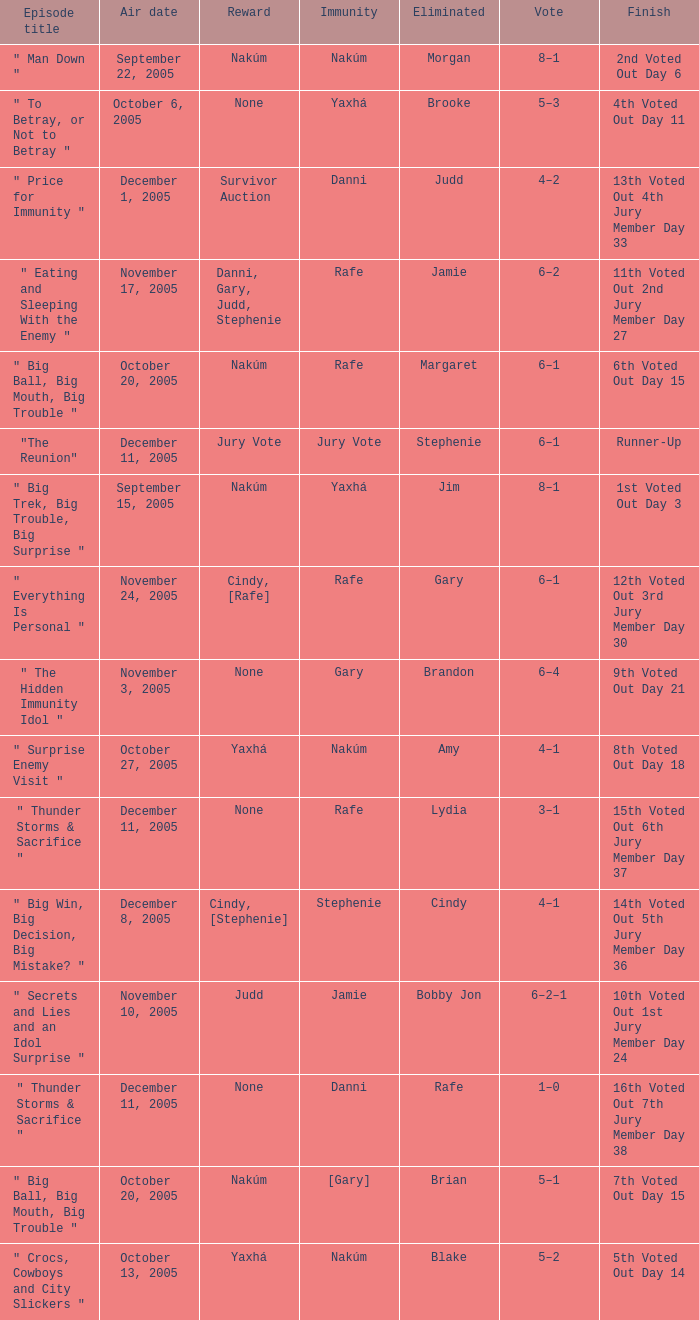When jim is eliminated what is the finish? 1st Voted Out Day 3. 